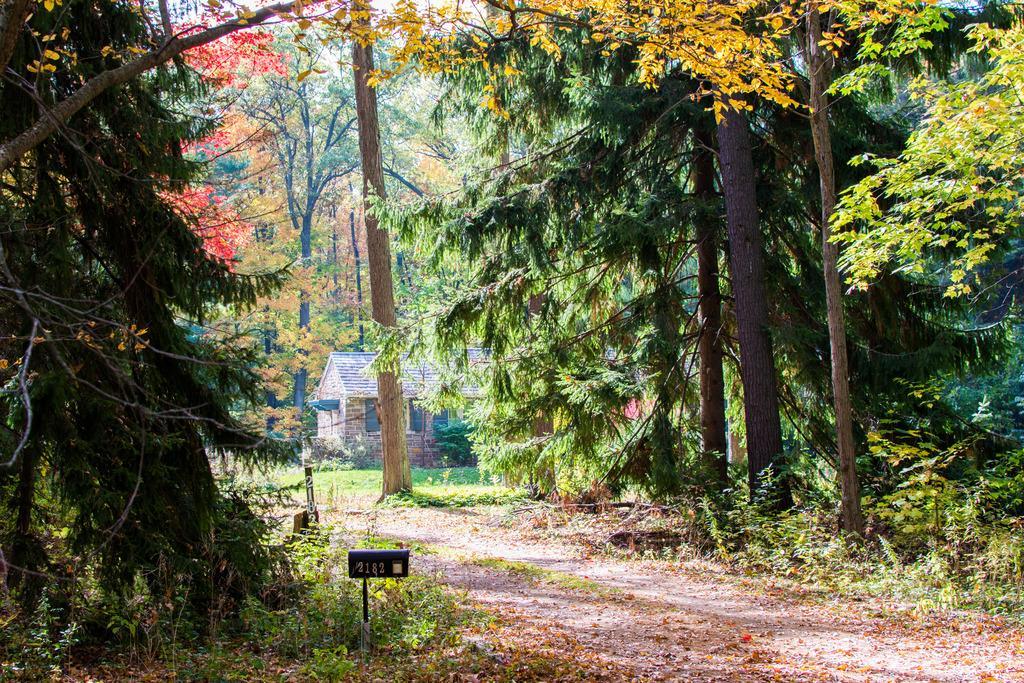Describe this image in one or two sentences. There is a road. On the sides of the road there are trees. In the back there is a building. 